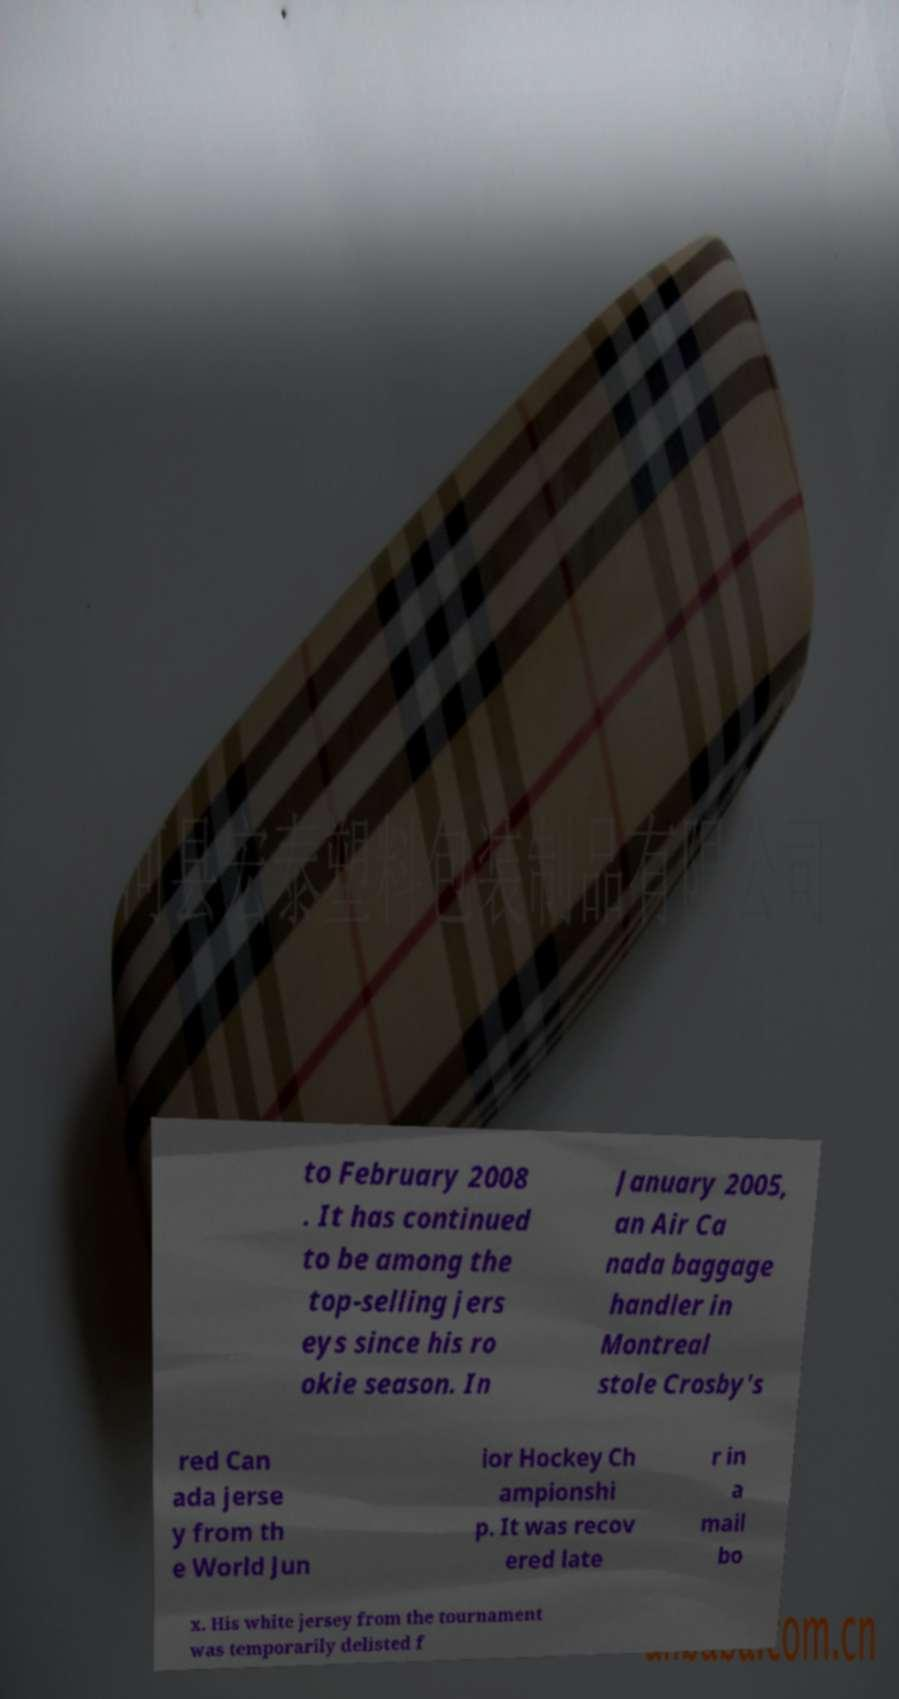I need the written content from this picture converted into text. Can you do that? to February 2008 . It has continued to be among the top-selling jers eys since his ro okie season. In January 2005, an Air Ca nada baggage handler in Montreal stole Crosby's red Can ada jerse y from th e World Jun ior Hockey Ch ampionshi p. It was recov ered late r in a mail bo x. His white jersey from the tournament was temporarily delisted f 